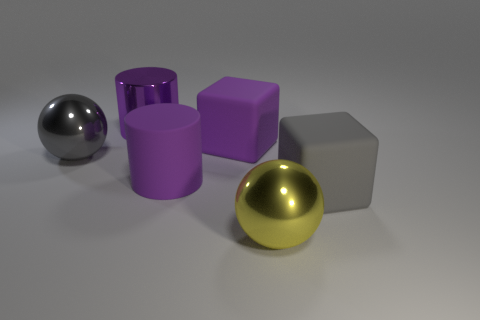There is a thing that is both in front of the large gray ball and to the left of the big yellow shiny object; what is it made of?
Offer a terse response. Rubber. There is a gray object on the left side of the shiny cylinder; does it have the same shape as the yellow object?
Offer a very short reply. Yes. Is the number of gray spheres less than the number of big cubes?
Offer a very short reply. Yes. How many large objects are the same color as the metal cylinder?
Ensure brevity in your answer.  2. There is another large cylinder that is the same color as the rubber cylinder; what material is it?
Provide a succinct answer. Metal. There is a large metal cylinder; is it the same color as the block that is right of the big yellow thing?
Your answer should be very brief. No. Is the number of large green rubber cylinders greater than the number of big purple metallic cylinders?
Your response must be concise. No. There is another thing that is the same shape as the gray rubber thing; what is its size?
Your answer should be compact. Large. Are the large gray block and the gray ball in front of the large shiny cylinder made of the same material?
Ensure brevity in your answer.  No. How many things are either green cylinders or matte blocks?
Your response must be concise. 2. 